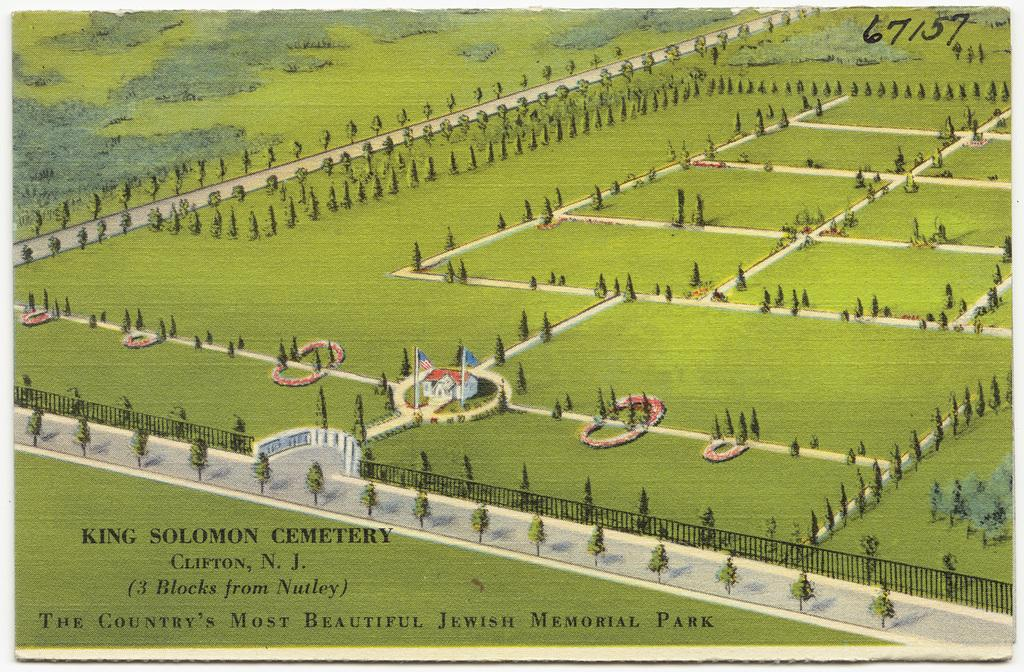<image>
Offer a succinct explanation of the picture presented. a green colored paper that says 'king solomon cemetery' on it 